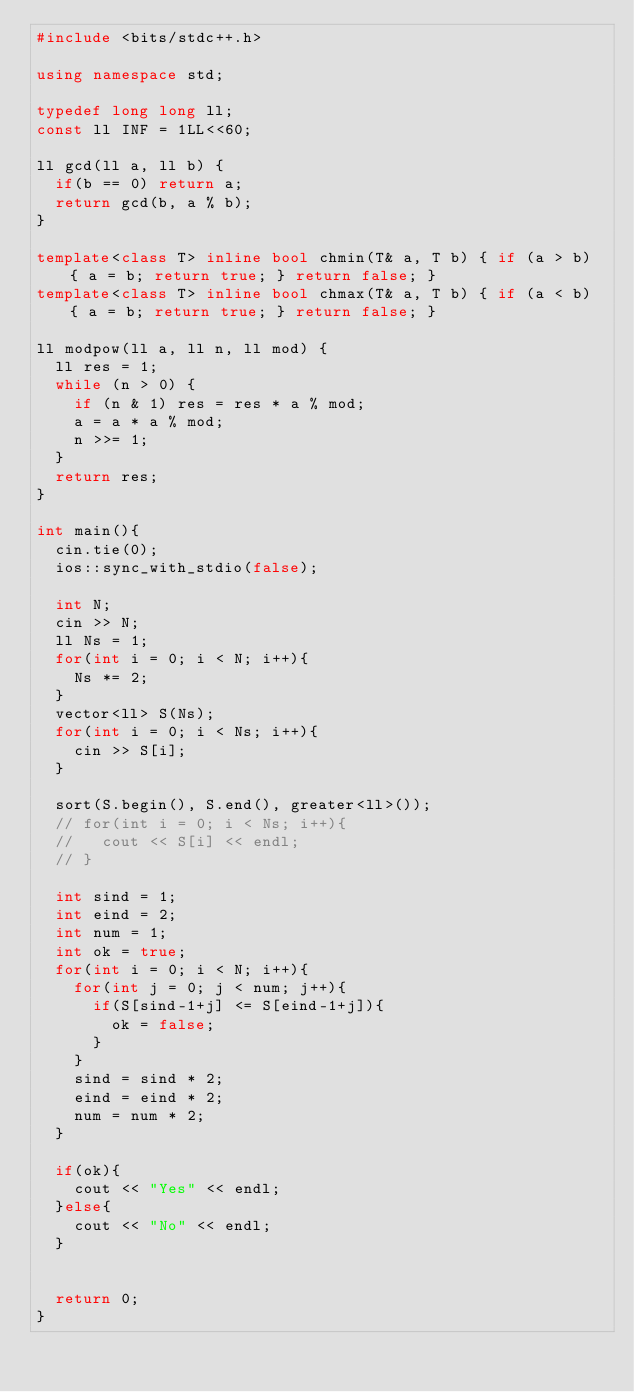<code> <loc_0><loc_0><loc_500><loc_500><_C++_>#include <bits/stdc++.h>

using namespace std;

typedef long long ll;
const ll INF = 1LL<<60;

ll gcd(ll a, ll b) {
  if(b == 0) return a;
  return gcd(b, a % b);
}

template<class T> inline bool chmin(T& a, T b) { if (a > b) { a = b; return true; } return false; }
template<class T> inline bool chmax(T& a, T b) { if (a < b) { a = b; return true; } return false; }

ll modpow(ll a, ll n, ll mod) {
  ll res = 1;
  while (n > 0) {
    if (n & 1) res = res * a % mod;
    a = a * a % mod;
    n >>= 1;
  }
  return res;
}

int main(){
  cin.tie(0);
  ios::sync_with_stdio(false);

  int N;
  cin >> N;
  ll Ns = 1;
  for(int i = 0; i < N; i++){
    Ns *= 2;
  }
  vector<ll> S(Ns);
  for(int i = 0; i < Ns; i++){
    cin >> S[i];
  }

  sort(S.begin(), S.end(), greater<ll>());
  // for(int i = 0; i < Ns; i++){
  //   cout << S[i] << endl;
  // }

  int sind = 1;
  int eind = 2;
  int num = 1;
  int ok = true;
  for(int i = 0; i < N; i++){
    for(int j = 0; j < num; j++){
      if(S[sind-1+j] <= S[eind-1+j]){
        ok = false;
      }
    }
    sind = sind * 2;
    eind = eind * 2;
    num = num * 2;
  }

  if(ok){
    cout << "Yes" << endl;
  }else{
    cout << "No" << endl;
  }
  

  return 0;
}

</code> 